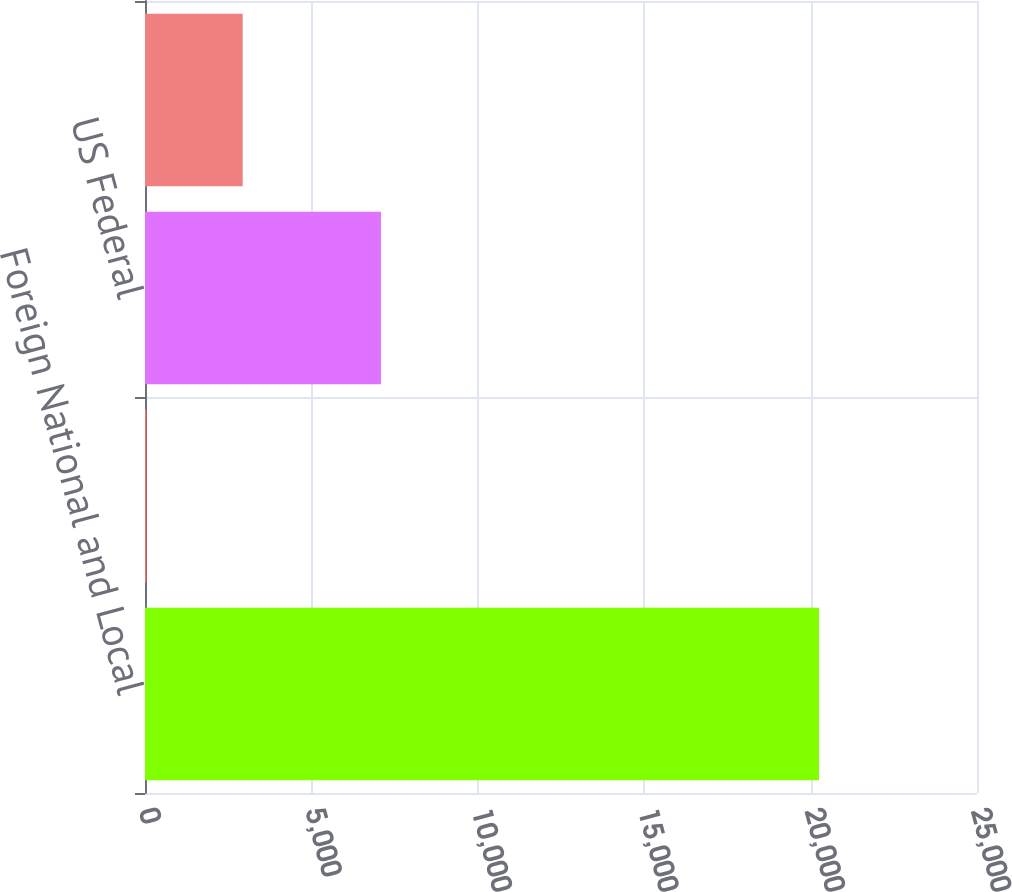<chart> <loc_0><loc_0><loc_500><loc_500><bar_chart><fcel>Foreign National and Local<fcel>Total<fcel>US Federal<fcel>Provision (benefit) for income<nl><fcel>20253<fcel>35<fcel>7090<fcel>2936<nl></chart> 